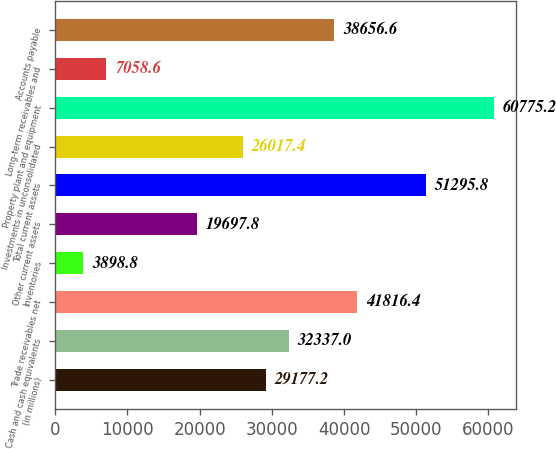Convert chart. <chart><loc_0><loc_0><loc_500><loc_500><bar_chart><fcel>(in millions)<fcel>Cash and cash equivalents<fcel>Trade receivables net<fcel>Inventories<fcel>Other current assets<fcel>Total current assets<fcel>Investments in unconsolidated<fcel>Property plant and equipment<fcel>Long-term receivables and<fcel>Accounts payable<nl><fcel>29177.2<fcel>32337<fcel>41816.4<fcel>3898.8<fcel>19697.8<fcel>51295.8<fcel>26017.4<fcel>60775.2<fcel>7058.6<fcel>38656.6<nl></chart> 